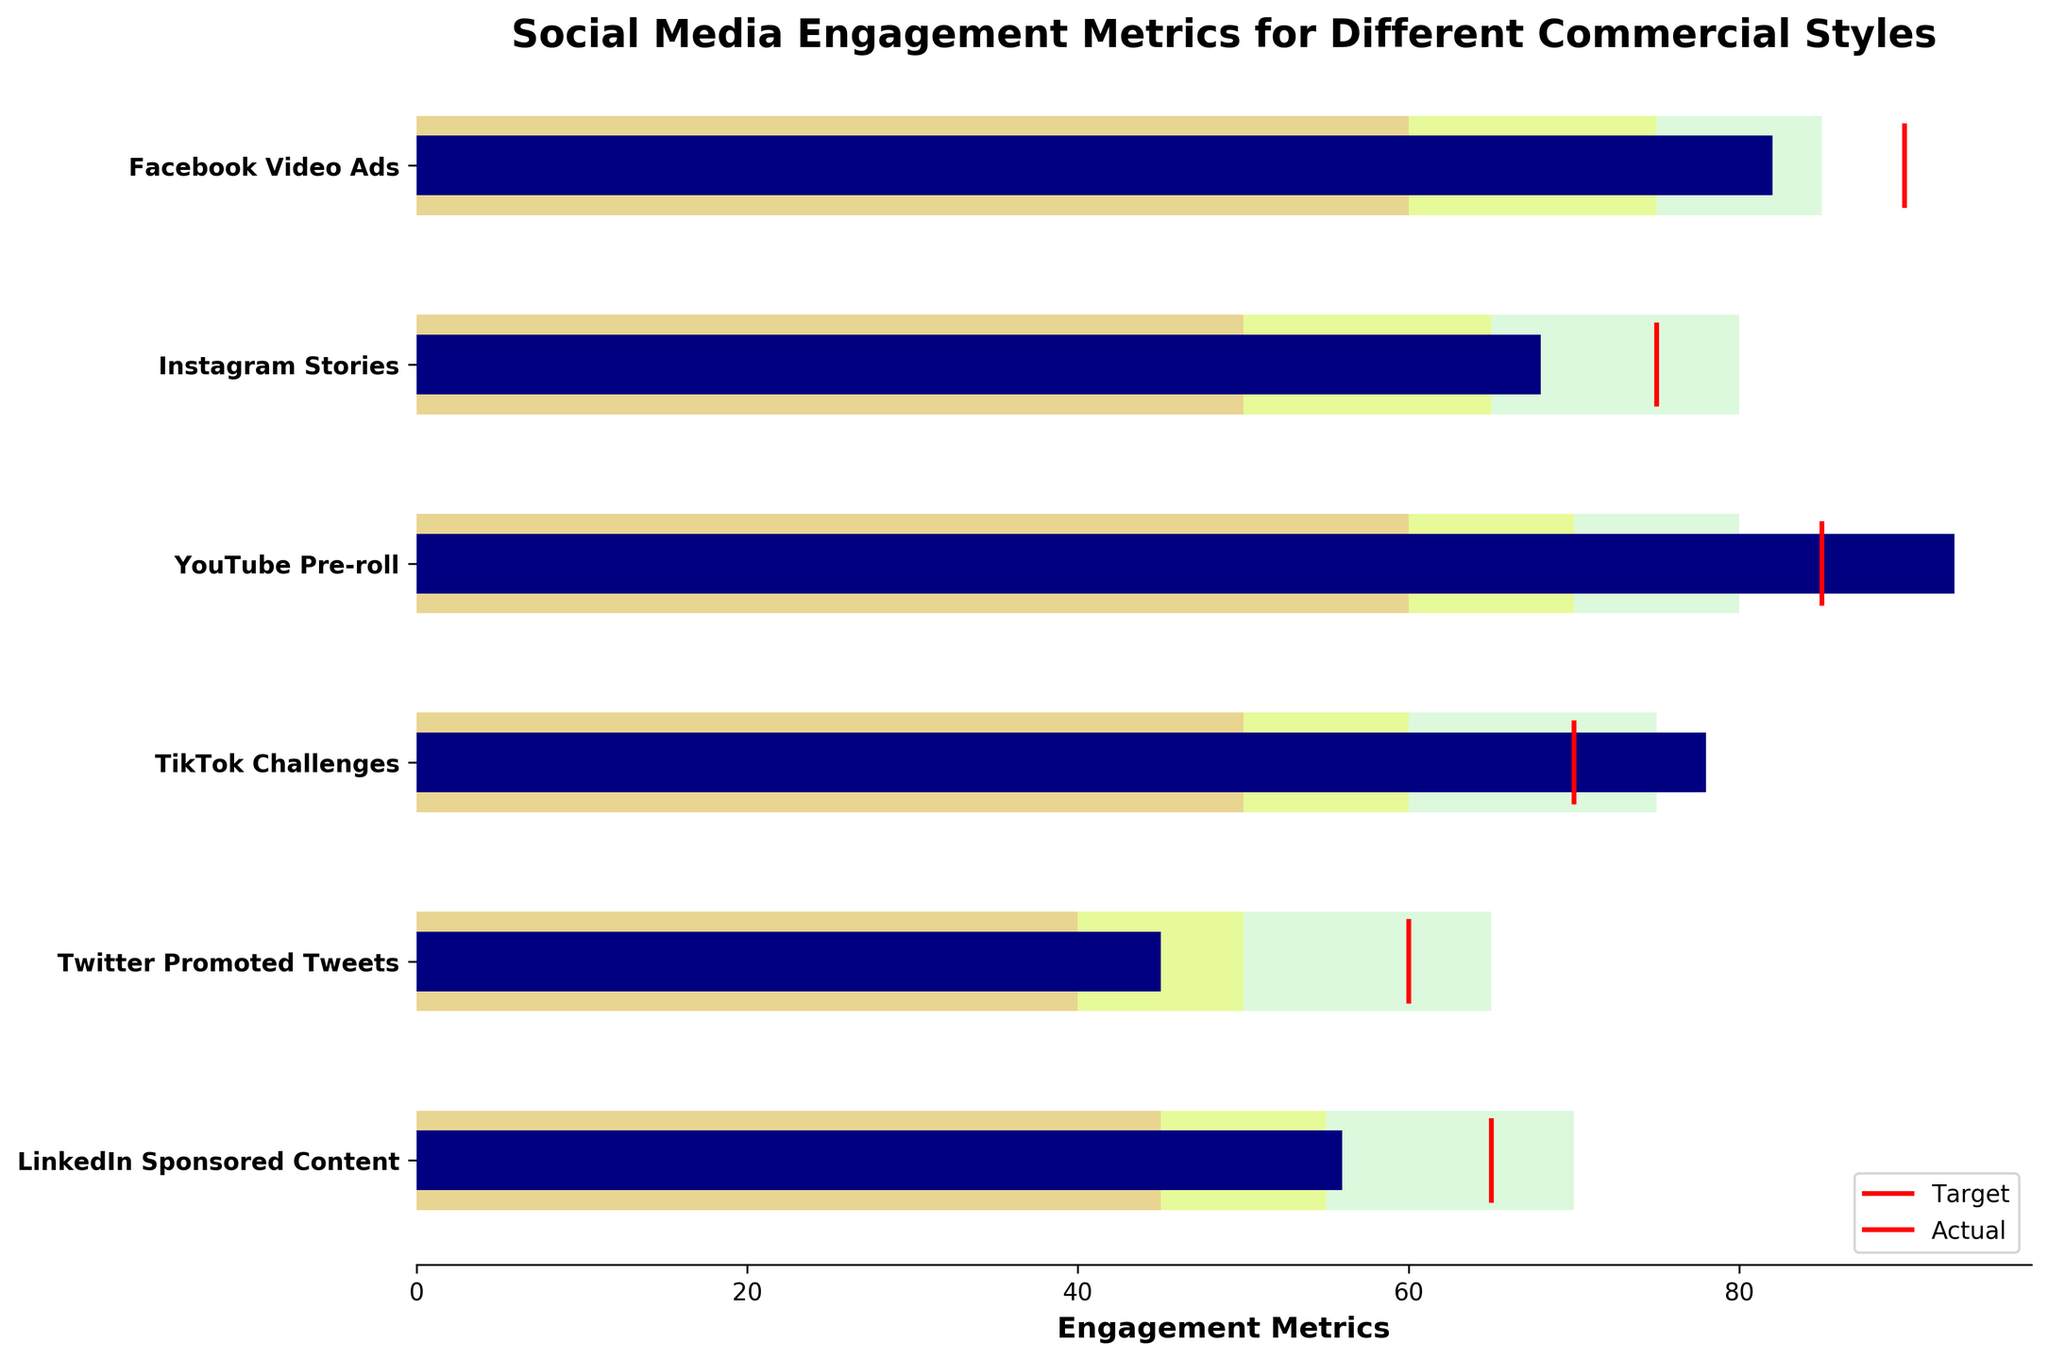what is the title of the figure? The title is usually shown at the top of the figure, and it is explicitly noted to help viewers understand the context of the data presented.
Answer: Social Media Engagement Metrics for Different Commercial Styles What is the color used to indicate "Actual" values? The color for "Actual" values is depicted in the legend of the figure, which helps to differentiate it from the background ranges.
Answer: navy Which social media platform has the highest actual engagement metrics? To find this, compare the height of the navy bars representing "Actual" values for each social media category. The tallest bar indicates the highest engagement.
Answer: YouTube Pre-roll What are the engagement goals for LinkedIn Sponsored Content? Engagement goals are represented by the red lines, and you'll find the specific target value for LinkedIn Sponsored Content by locating it in the figure.
Answer: 65 Which commercial style has the widest margin between its actual and target engagement metrics? Calculate the difference between actual and target values for each category and compare them. The widest margin indicates the greatest difference.
Answer: Twitter Promoted Tweets In which category does the actual engagement metric fall into the "Good" range? Compare the actual value (navy bar) with the ranges defined by "Poor," "Satisfactory," and "Good" for each category. The "Good" range is the highest among them.
Answer: TikTok Challenges How many social media platforms met or exceeded their engagement targets? Count the number of categories where the "Actual" value (navy bar) reaches or surpasses the red line representing the target.
Answer: 2 (YouTube Pre-roll and TikTok Challenges) What is the difference between the actual engagement metrics of Facebook Video Ads and Instagram Stories? Subtract the actual value of Instagram Stories from the actual value of Facebook Video Ads to see the difference.
Answer: 14 Which commercial style's actual engagement is closest to its satisfactory range's upper limit? Check each category's actual value (navy bar) and compare it to the top of the satisfactory range (yellow bar's upper limit) to find the closest match.
Answer: Facebook Video Ads How well did Twitter Promoted Tweets perform compared to their determined goals? Look at the "Actual" value (navy bar) and compare it to the target value (red line) and the satisfactory range (yellow bar) for Twitter Promoted Tweets to evaluate its performance.
Answer: Below satisfactory, far from target 